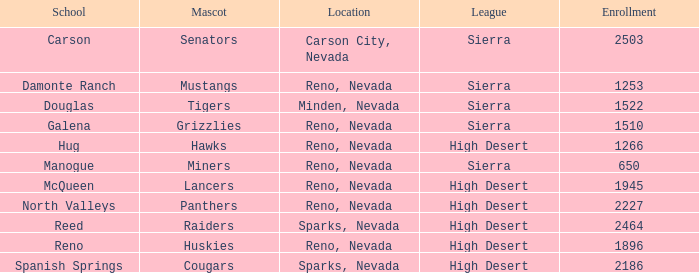Can you give me this table as a dict? {'header': ['School', 'Mascot', 'Location', 'League', 'Enrollment'], 'rows': [['Carson', 'Senators', 'Carson City, Nevada', 'Sierra', '2503'], ['Damonte Ranch', 'Mustangs', 'Reno, Nevada', 'Sierra', '1253'], ['Douglas', 'Tigers', 'Minden, Nevada', 'Sierra', '1522'], ['Galena', 'Grizzlies', 'Reno, Nevada', 'Sierra', '1510'], ['Hug', 'Hawks', 'Reno, Nevada', 'High Desert', '1266'], ['Manogue', 'Miners', 'Reno, Nevada', 'Sierra', '650'], ['McQueen', 'Lancers', 'Reno, Nevada', 'High Desert', '1945'], ['North Valleys', 'Panthers', 'Reno, Nevada', 'High Desert', '2227'], ['Reed', 'Raiders', 'Sparks, Nevada', 'High Desert', '2464'], ['Reno', 'Huskies', 'Reno, Nevada', 'High Desert', '1896'], ['Spanish Springs', 'Cougars', 'Sparks, Nevada', 'High Desert', '2186']]} Which competitions feature raiders as their symbol? High Desert. 